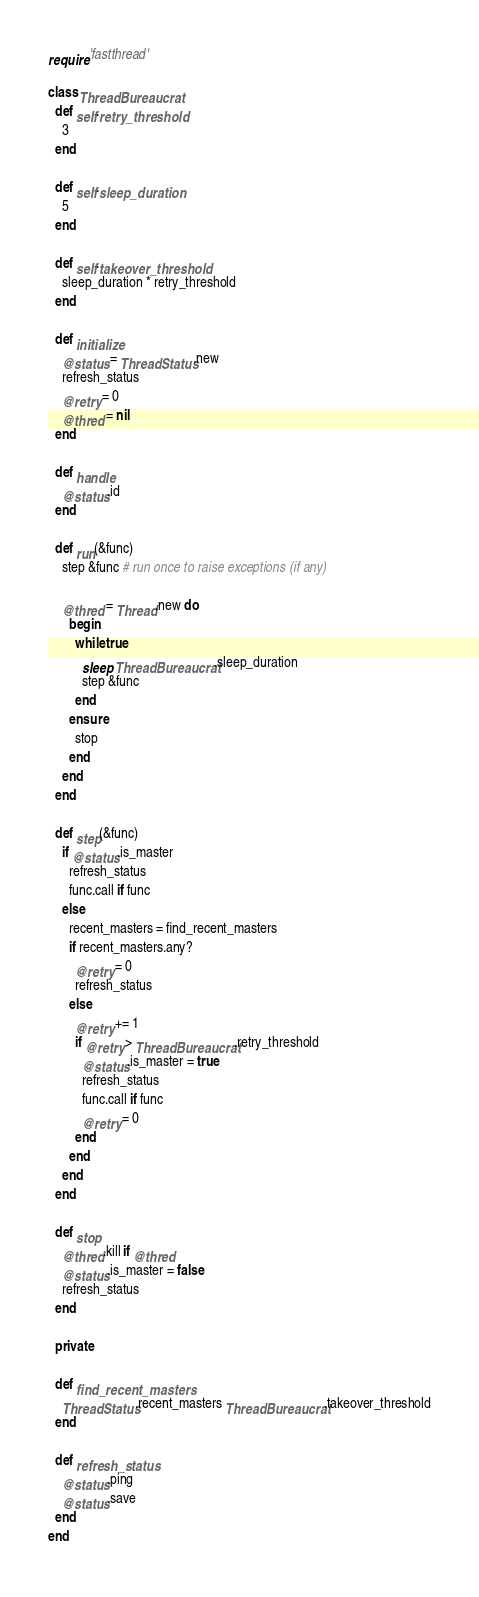Convert code to text. <code><loc_0><loc_0><loc_500><loc_500><_Ruby_>require 'fastthread'

class ThreadBureaucrat
  def self.retry_threshold
    3
  end
  
  def self.sleep_duration
    5
  end
  
  def self.takeover_threshold
    sleep_duration * retry_threshold
  end
  
  def initialize
    @status = ThreadStatus.new
    refresh_status
    @retry = 0
    @thred = nil
  end
  
  def handle
    @status.id
  end
  
  def run(&func)
    step &func # run once to raise exceptions (if any)
    
    @thred = Thread.new do
      begin
        while true
          sleep ThreadBureaucrat.sleep_duration
          step &func
        end
      ensure
        stop
      end
    end
  end
  
  def step(&func)
    if @status.is_master
      refresh_status
      func.call if func
    else
      recent_masters = find_recent_masters
      if recent_masters.any?
        @retry = 0
        refresh_status
      else
        @retry += 1
        if @retry > ThreadBureaucrat.retry_threshold
          @status.is_master = true
          refresh_status
          func.call if func
          @retry = 0
        end
      end
    end
  end
  
  def stop
    @thred.kill if @thred
    @status.is_master = false
    refresh_status
  end
  
  private
  
  def find_recent_masters
    ThreadStatus.recent_masters ThreadBureaucrat.takeover_threshold
  end
  
  def refresh_status
    @status.ping
    @status.save
  end
end</code> 